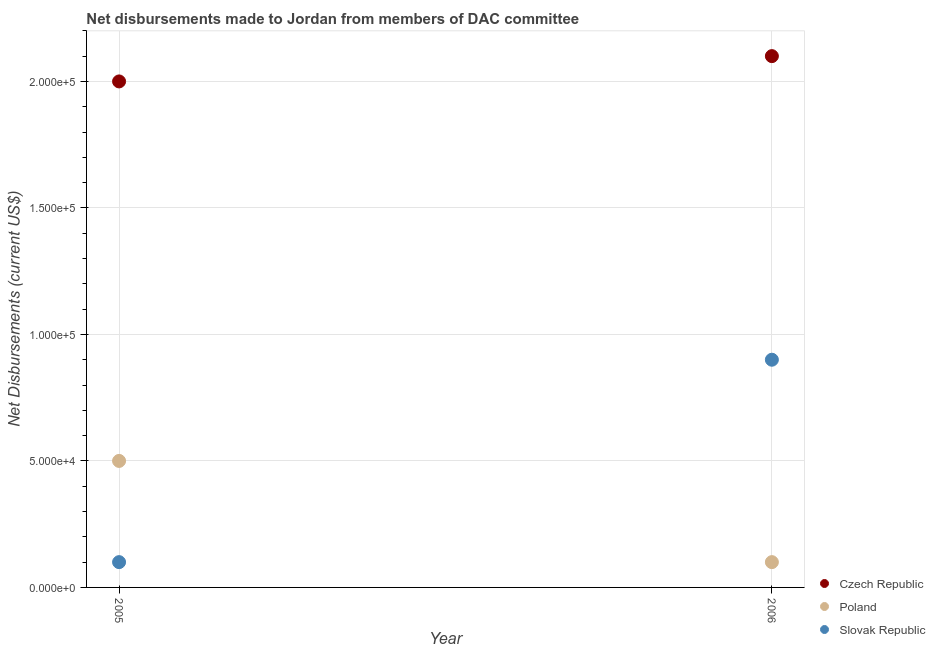Is the number of dotlines equal to the number of legend labels?
Your answer should be compact. Yes. What is the net disbursements made by czech republic in 2005?
Provide a short and direct response. 2.00e+05. Across all years, what is the maximum net disbursements made by slovak republic?
Give a very brief answer. 9.00e+04. Across all years, what is the minimum net disbursements made by poland?
Offer a terse response. 10000. What is the total net disbursements made by poland in the graph?
Provide a succinct answer. 6.00e+04. What is the difference between the net disbursements made by poland in 2005 and that in 2006?
Your answer should be very brief. 4.00e+04. What is the difference between the net disbursements made by poland in 2006 and the net disbursements made by czech republic in 2005?
Your answer should be very brief. -1.90e+05. In the year 2006, what is the difference between the net disbursements made by poland and net disbursements made by slovak republic?
Keep it short and to the point. -8.00e+04. In how many years, is the net disbursements made by slovak republic greater than 110000 US$?
Provide a short and direct response. 0. What is the ratio of the net disbursements made by poland in 2005 to that in 2006?
Make the answer very short. 5. Is the net disbursements made by slovak republic in 2005 less than that in 2006?
Your answer should be very brief. Yes. In how many years, is the net disbursements made by czech republic greater than the average net disbursements made by czech republic taken over all years?
Give a very brief answer. 1. Does the net disbursements made by poland monotonically increase over the years?
Your answer should be very brief. No. Is the net disbursements made by poland strictly greater than the net disbursements made by czech republic over the years?
Keep it short and to the point. No. Is the net disbursements made by poland strictly less than the net disbursements made by czech republic over the years?
Keep it short and to the point. Yes. How many dotlines are there?
Offer a terse response. 3. How many years are there in the graph?
Offer a terse response. 2. What is the difference between two consecutive major ticks on the Y-axis?
Provide a succinct answer. 5.00e+04. How many legend labels are there?
Give a very brief answer. 3. How are the legend labels stacked?
Ensure brevity in your answer.  Vertical. What is the title of the graph?
Provide a succinct answer. Net disbursements made to Jordan from members of DAC committee. What is the label or title of the X-axis?
Give a very brief answer. Year. What is the label or title of the Y-axis?
Offer a terse response. Net Disbursements (current US$). What is the Net Disbursements (current US$) of Poland in 2006?
Make the answer very short. 10000. What is the Net Disbursements (current US$) of Slovak Republic in 2006?
Ensure brevity in your answer.  9.00e+04. Across all years, what is the maximum Net Disbursements (current US$) in Czech Republic?
Your response must be concise. 2.10e+05. Across all years, what is the maximum Net Disbursements (current US$) in Poland?
Your response must be concise. 5.00e+04. Across all years, what is the maximum Net Disbursements (current US$) of Slovak Republic?
Your answer should be compact. 9.00e+04. What is the total Net Disbursements (current US$) of Slovak Republic in the graph?
Provide a succinct answer. 1.00e+05. What is the difference between the Net Disbursements (current US$) in Czech Republic in 2005 and that in 2006?
Offer a terse response. -10000. What is the difference between the Net Disbursements (current US$) in Poland in 2005 and that in 2006?
Provide a succinct answer. 4.00e+04. What is the difference between the Net Disbursements (current US$) of Czech Republic in 2005 and the Net Disbursements (current US$) of Poland in 2006?
Offer a terse response. 1.90e+05. What is the difference between the Net Disbursements (current US$) of Czech Republic in 2005 and the Net Disbursements (current US$) of Slovak Republic in 2006?
Keep it short and to the point. 1.10e+05. What is the difference between the Net Disbursements (current US$) of Poland in 2005 and the Net Disbursements (current US$) of Slovak Republic in 2006?
Your response must be concise. -4.00e+04. What is the average Net Disbursements (current US$) in Czech Republic per year?
Keep it short and to the point. 2.05e+05. In the year 2005, what is the difference between the Net Disbursements (current US$) in Poland and Net Disbursements (current US$) in Slovak Republic?
Your answer should be compact. 4.00e+04. In the year 2006, what is the difference between the Net Disbursements (current US$) of Czech Republic and Net Disbursements (current US$) of Slovak Republic?
Offer a terse response. 1.20e+05. What is the ratio of the Net Disbursements (current US$) in Czech Republic in 2005 to that in 2006?
Your answer should be very brief. 0.95. What is the ratio of the Net Disbursements (current US$) of Poland in 2005 to that in 2006?
Offer a terse response. 5. What is the ratio of the Net Disbursements (current US$) in Slovak Republic in 2005 to that in 2006?
Offer a terse response. 0.11. What is the difference between the highest and the second highest Net Disbursements (current US$) in Czech Republic?
Keep it short and to the point. 10000. What is the difference between the highest and the second highest Net Disbursements (current US$) in Slovak Republic?
Offer a terse response. 8.00e+04. What is the difference between the highest and the lowest Net Disbursements (current US$) in Czech Republic?
Keep it short and to the point. 10000. What is the difference between the highest and the lowest Net Disbursements (current US$) in Slovak Republic?
Offer a terse response. 8.00e+04. 